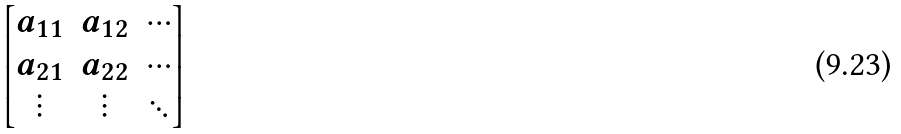<formula> <loc_0><loc_0><loc_500><loc_500>\begin{bmatrix} a _ { 1 1 } & a _ { 1 2 } & \cdots \\ a _ { 2 1 } & a _ { 2 2 } & \cdots \\ \vdots & \vdots & \ddots \end{bmatrix}</formula> 